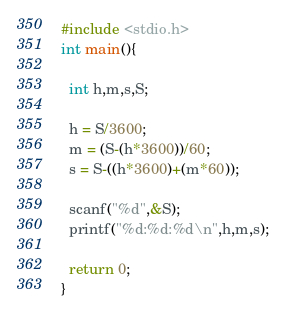<code> <loc_0><loc_0><loc_500><loc_500><_C_>#include <stdio.h>
int main(){

  int h,m,s,S;

  h = S/3600;
  m = (S-(h*3600))/60;
  s = S-((h*3600)+(m*60));

  scanf("%d",&S); 
  printf("%d:%d:%d\n",h,m,s);

  return 0;
}</code> 